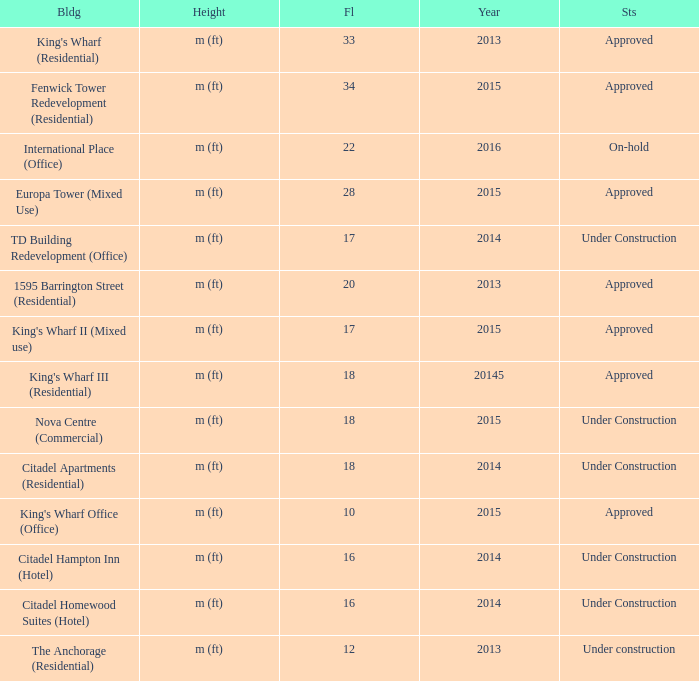What is the status of the building with more than 28 floor and a year of 2013? Approved. 